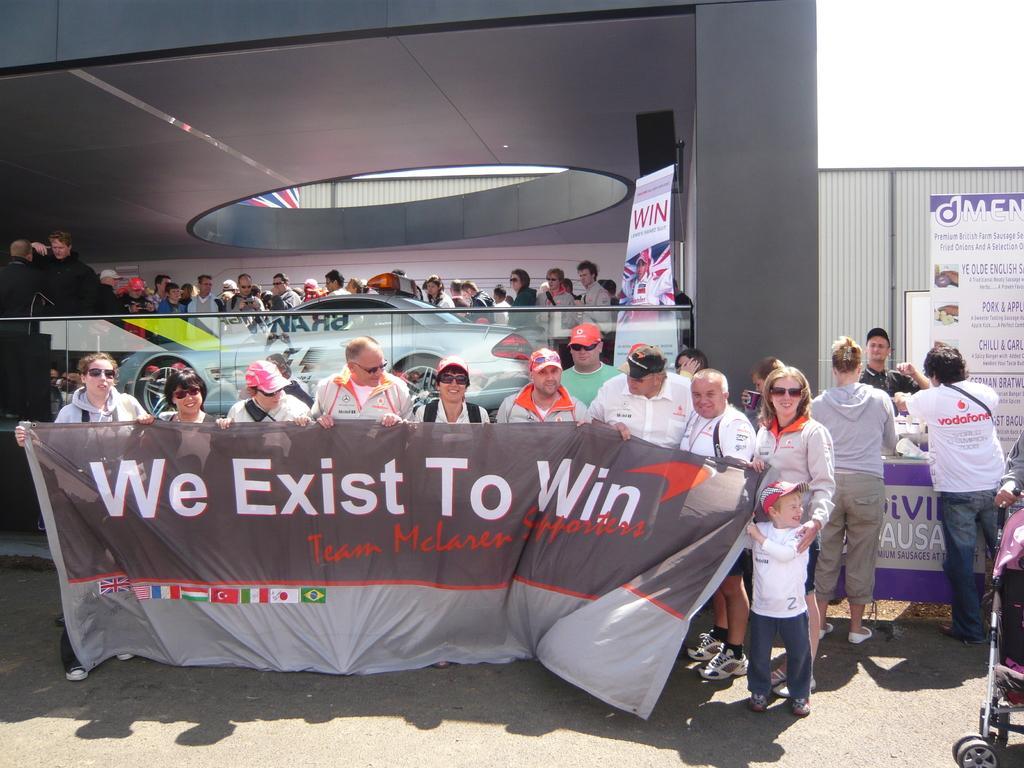Can you describe this image briefly? In this image we can see a few people standing and holding the banner, some written text on it, near that we can see the table and few objects on it, we can see the written text on the board, behind we can see the car, glass fence, ceiling, we can see the sky. 